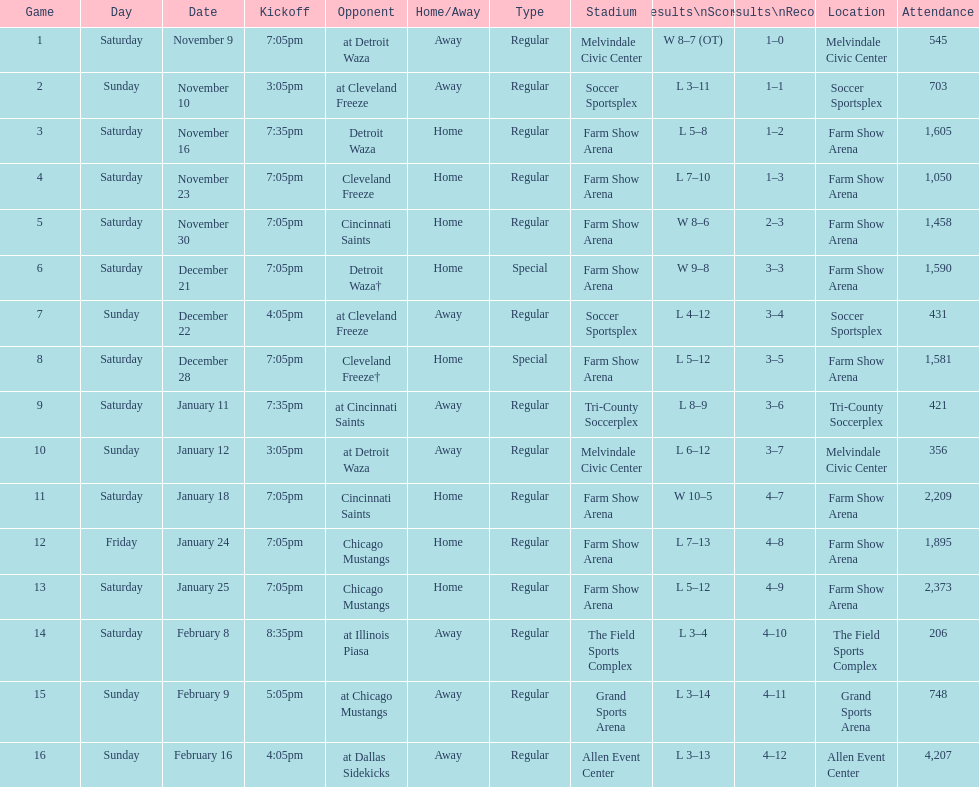Which opponent is listed first in the table? Detroit Waza. 